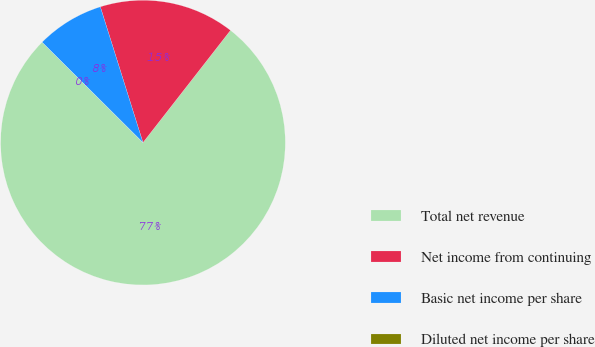Convert chart. <chart><loc_0><loc_0><loc_500><loc_500><pie_chart><fcel>Total net revenue<fcel>Net income from continuing<fcel>Basic net income per share<fcel>Diluted net income per share<nl><fcel>76.92%<fcel>15.38%<fcel>7.69%<fcel>0.0%<nl></chart> 